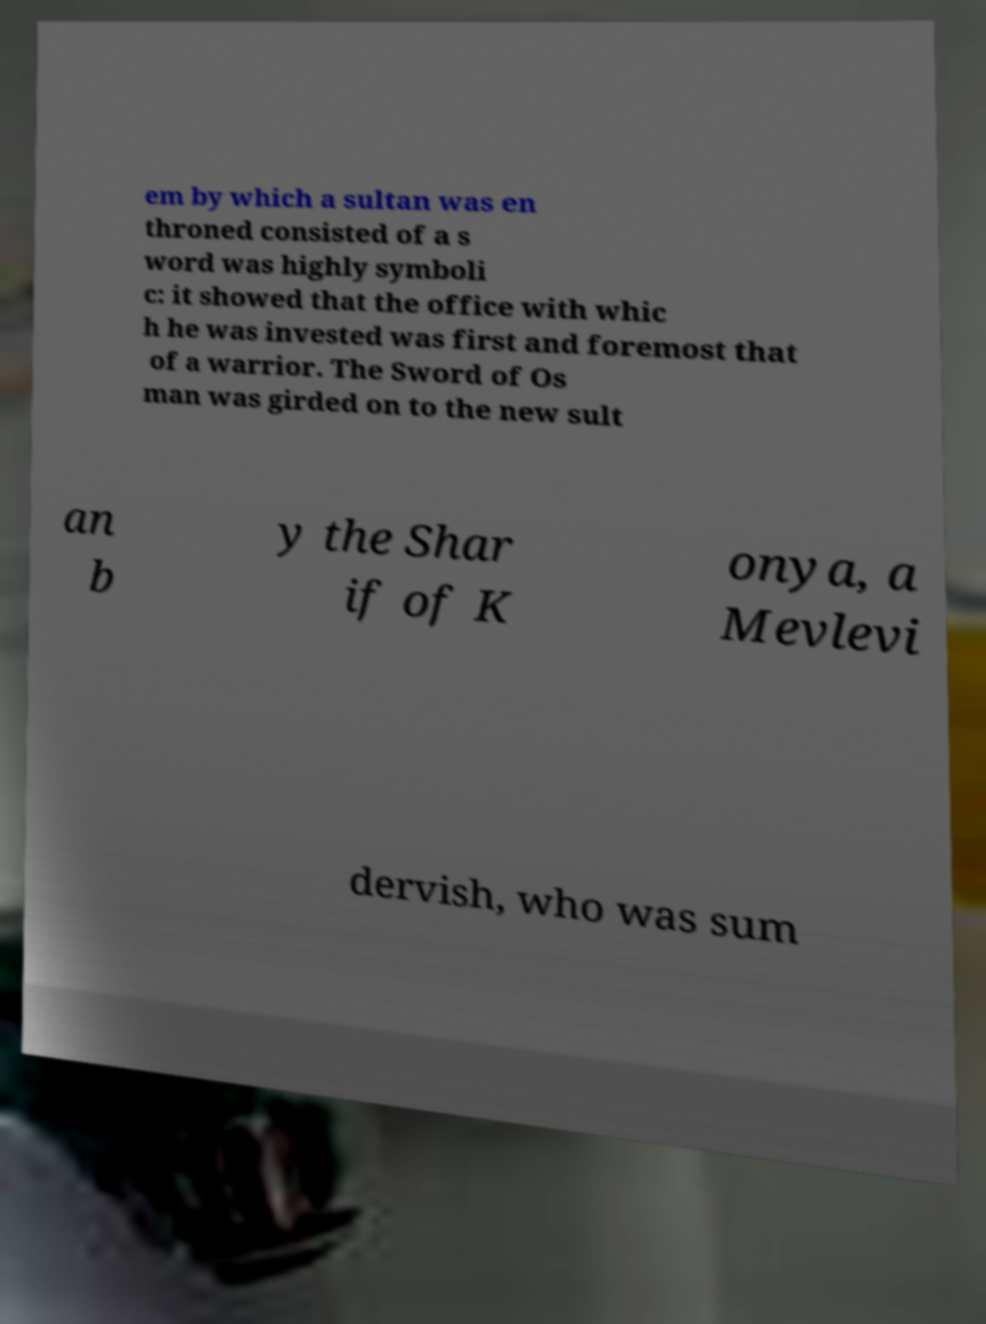Can you accurately transcribe the text from the provided image for me? em by which a sultan was en throned consisted of a s word was highly symboli c: it showed that the office with whic h he was invested was first and foremost that of a warrior. The Sword of Os man was girded on to the new sult an b y the Shar if of K onya, a Mevlevi dervish, who was sum 